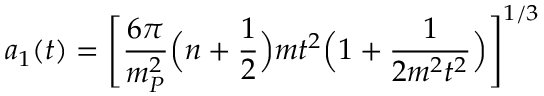<formula> <loc_0><loc_0><loc_500><loc_500>a _ { 1 } ( t ) = \left [ \frac { 6 \pi } { m _ { P } ^ { 2 } } \left ( n + \frac { 1 } { 2 } \right ) m t ^ { 2 } \left ( 1 + \frac { 1 } { 2 m ^ { 2 } t ^ { 2 } } \right ) \right ] ^ { 1 / 3 }</formula> 